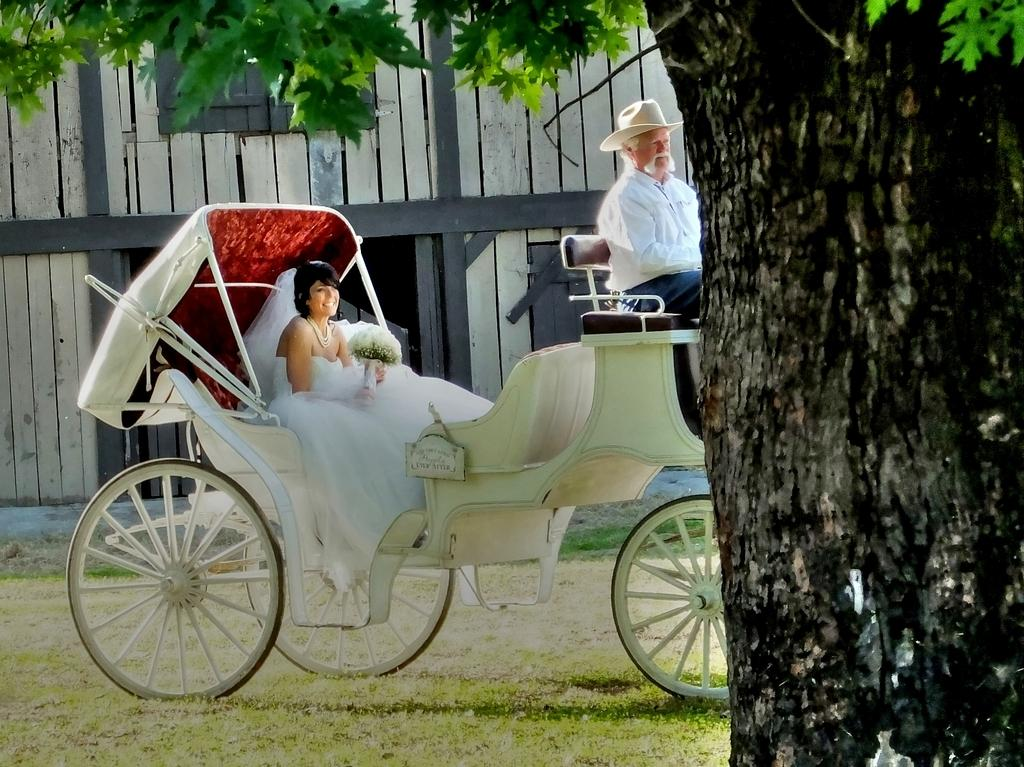What is the main subject of the image? There is a person riding a cart in the image. Who else is present in the image? A lady is sitting in the cart. What is the lady holding in the image? The lady is holding a bouquet. Can you describe the tree in the image? There is a tree with a big trunk in the image. How many snails can be seen crawling on the cart in the image? There are no snails visible in the image; it only features a person riding a cart, a lady sitting in the cart, and a lady holding a bouquet. What type of bell is attached to the cart in the image? There is no bell present on the cart in the image. 